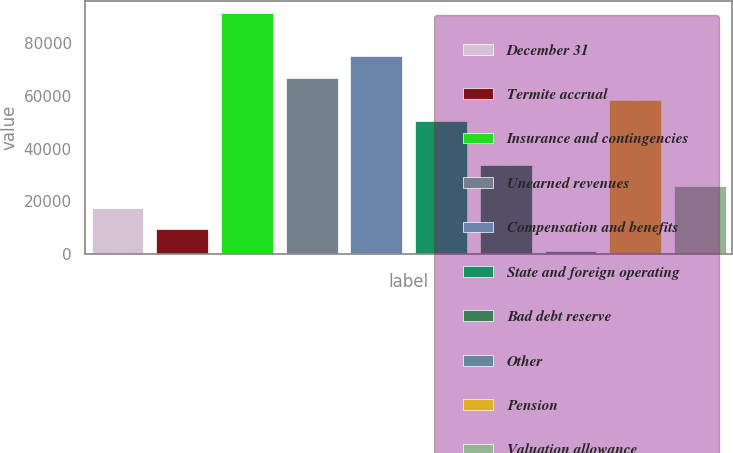Convert chart. <chart><loc_0><loc_0><loc_500><loc_500><bar_chart><fcel>December 31<fcel>Termite accrual<fcel>Insurance and contingencies<fcel>Unearned revenues<fcel>Compensation and benefits<fcel>State and foreign operating<fcel>Bad debt reserve<fcel>Other<fcel>Pension<fcel>Valuation allowance<nl><fcel>17602.6<fcel>9409.8<fcel>91337.8<fcel>66759.4<fcel>74952.2<fcel>50373.8<fcel>33988.2<fcel>1217<fcel>58566.6<fcel>25795.4<nl></chart> 